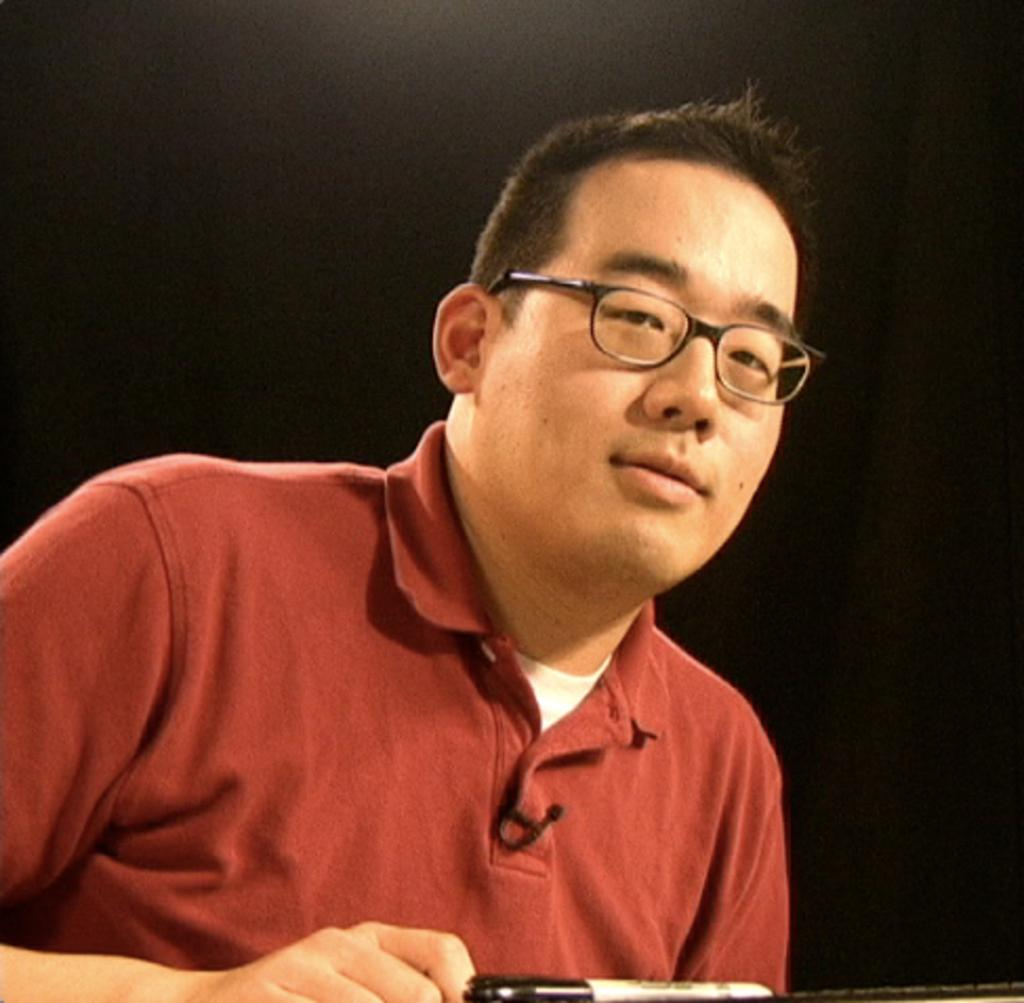What is present in the image? There is a man in the image. What is the man wearing in the image? The man is wearing a red t-shirt. What accessory is the man wearing in the image? The man is wearing spectacles. What shape is the volcano in the image? There is no volcano present in the image. What type of committee is the man a part of in the image? There is no committee or any indication of the man's affiliations in the image. 